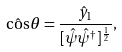<formula> <loc_0><loc_0><loc_500><loc_500>\hat { \cos } \theta = \frac { \hat { y } _ { 1 } } { [ \hat { \psi } \hat { \psi } ^ { \dag } ] ^ { \frac { 1 } { 2 } } } ,</formula> 